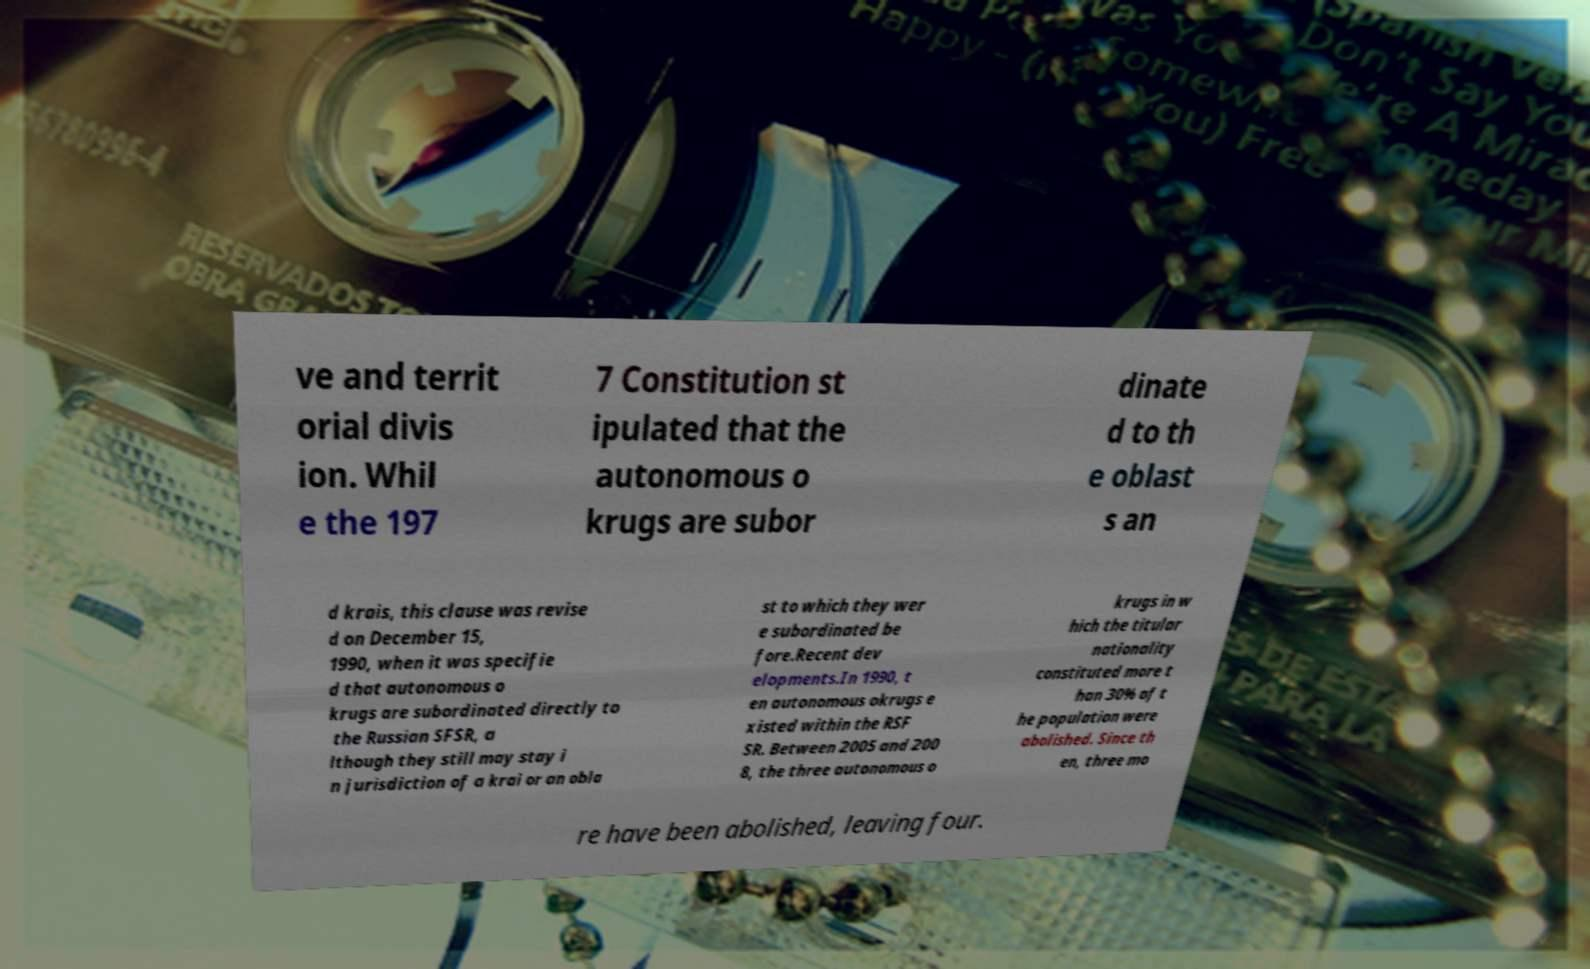Can you accurately transcribe the text from the provided image for me? ve and territ orial divis ion. Whil e the 197 7 Constitution st ipulated that the autonomous o krugs are subor dinate d to th e oblast s an d krais, this clause was revise d on December 15, 1990, when it was specifie d that autonomous o krugs are subordinated directly to the Russian SFSR, a lthough they still may stay i n jurisdiction of a krai or an obla st to which they wer e subordinated be fore.Recent dev elopments.In 1990, t en autonomous okrugs e xisted within the RSF SR. Between 2005 and 200 8, the three autonomous o krugs in w hich the titular nationality constituted more t han 30% of t he population were abolished. Since th en, three mo re have been abolished, leaving four. 